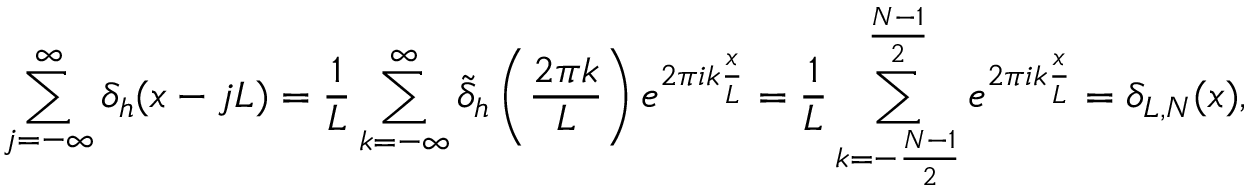<formula> <loc_0><loc_0><loc_500><loc_500>\sum _ { j = - \infty } ^ { \infty } \delta _ { h } ( x - j L ) = \frac { 1 } { L } \sum _ { k = - \infty } ^ { \infty } \tilde { \delta } _ { h } \left ( \frac { 2 \pi k } { L } \right ) e ^ { 2 \pi i k \frac { x } { L } } = \frac { 1 } { L } \sum _ { k = - \frac { N - 1 } { 2 } } ^ { \frac { N - 1 } { 2 } } e ^ { 2 \pi i k \frac { x } { L } } = \delta _ { L , N } ( x ) ,</formula> 